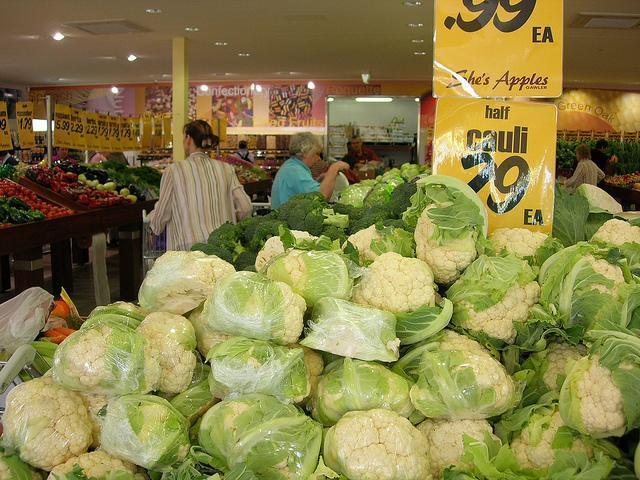How many broccolis are in the picture?
Give a very brief answer. 2. How many people can you see?
Give a very brief answer. 2. How many people on any type of bike are facing the camera?
Give a very brief answer. 0. 